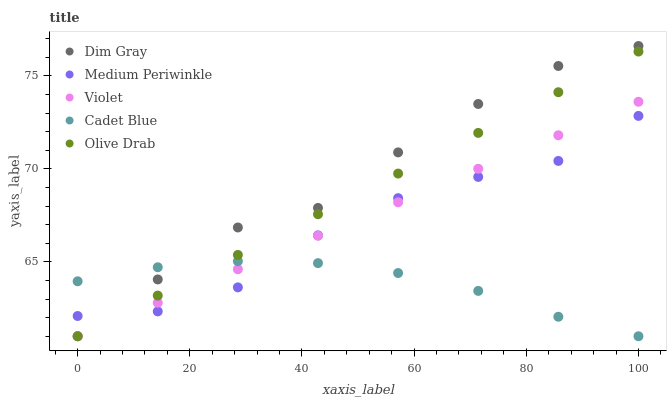Does Cadet Blue have the minimum area under the curve?
Answer yes or no. Yes. Does Dim Gray have the maximum area under the curve?
Answer yes or no. Yes. Does Medium Periwinkle have the minimum area under the curve?
Answer yes or no. No. Does Medium Periwinkle have the maximum area under the curve?
Answer yes or no. No. Is Violet the smoothest?
Answer yes or no. Yes. Is Medium Periwinkle the roughest?
Answer yes or no. Yes. Is Dim Gray the smoothest?
Answer yes or no. No. Is Dim Gray the roughest?
Answer yes or no. No. Does Cadet Blue have the lowest value?
Answer yes or no. Yes. Does Medium Periwinkle have the lowest value?
Answer yes or no. No. Does Dim Gray have the highest value?
Answer yes or no. Yes. Does Medium Periwinkle have the highest value?
Answer yes or no. No. Does Violet intersect Medium Periwinkle?
Answer yes or no. Yes. Is Violet less than Medium Periwinkle?
Answer yes or no. No. Is Violet greater than Medium Periwinkle?
Answer yes or no. No. 